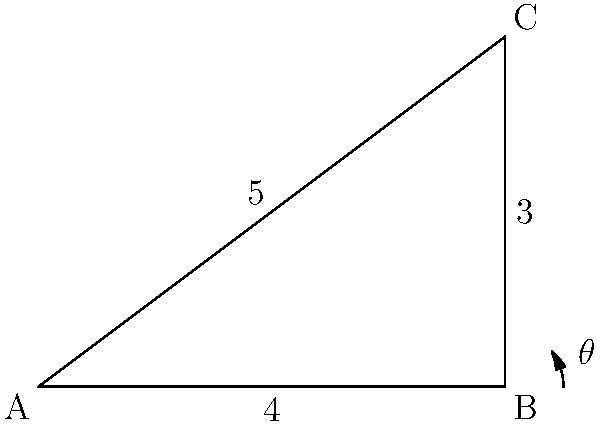In a food packaging facility, two conveyor belts meet at point B, forming a right angle. One belt runs from point A to B, with a length of 4 meters, while the other runs from B to C, with a length of 3 meters. What is the angle $\theta$ (in degrees) between the diagonal line AC and the conveyor belt AB? To solve this problem, we can follow these steps:

1) First, we recognize that we have a right-angled triangle ABC, where:
   - AB = 4 meters
   - BC = 3 meters
   - Angle ABC = 90°

2) We can find the length of AC using the Pythagorean theorem:
   $AC^2 = AB^2 + BC^2$
   $AC^2 = 4^2 + 3^2 = 16 + 9 = 25$
   $AC = \sqrt{25} = 5$ meters

3) Now we have a triangle with known side lengths: 4, 5, and 3.

4) To find the angle $\theta$, we can use the cosine law:
   $\cos \theta = \frac{AB^2 + AC^2 - BC^2}{2(AB)(AC)}$

5) Substituting the values:
   $\cos \theta = \frac{4^2 + 5^2 - 3^2}{2(4)(5)}$
   $= \frac{16 + 25 - 9}{40} = \frac{32}{40} = 0.8$

6) To get $\theta$, we take the inverse cosine (arccos):
   $\theta = \arccos(0.8)$

7) Converting to degrees:
   $\theta \approx 36.87°$

Therefore, the angle between the diagonal line AC and the conveyor belt AB is approximately 36.87°.
Answer: $36.87°$ 